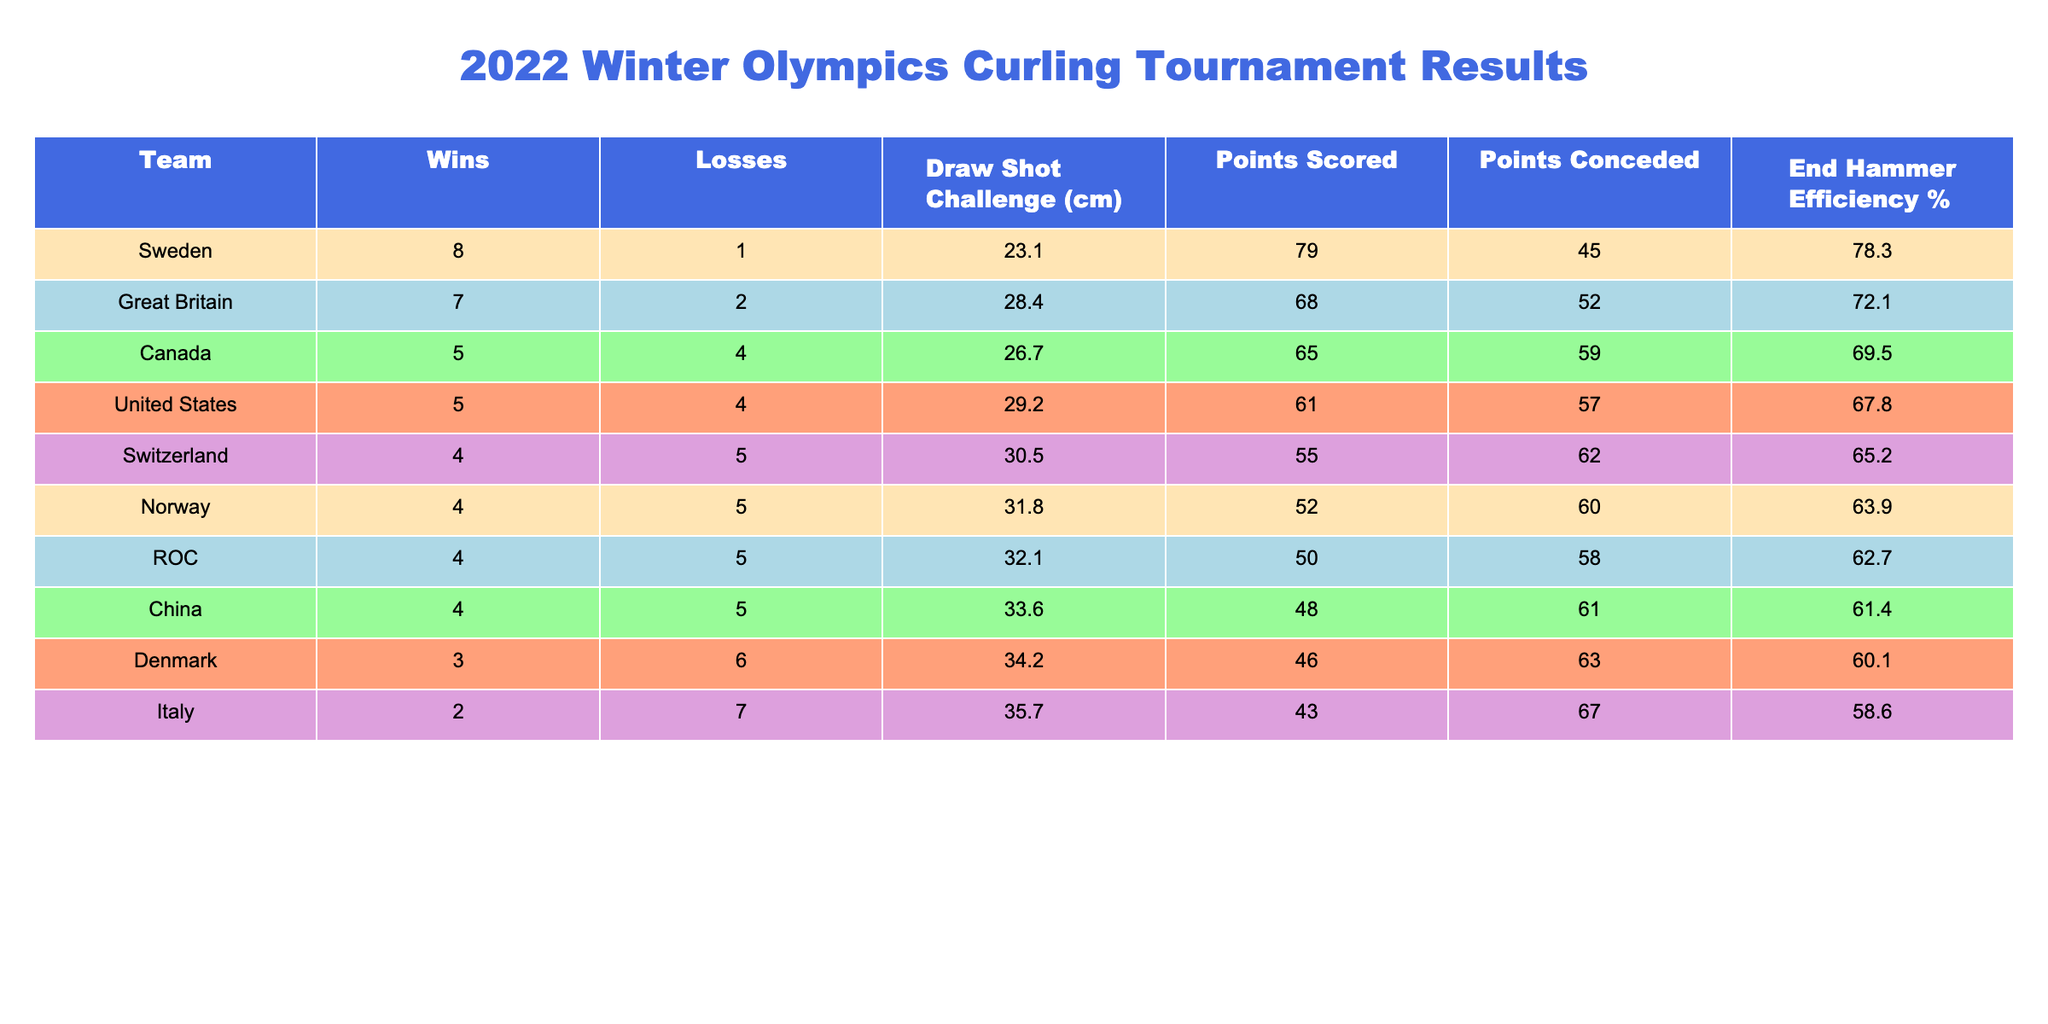What is the total number of wins for all teams? To find the total number of wins, we sum the wins for each team: 8 + 7 + 5 + 5 + 4 + 4 + 4 + 4 + 3 + 2 = 56.
Answer: 56 Which team conceded the most points? By looking at the "Points Conceded" column, we identify that Canada with 59 points conceded the most.
Answer: Canada What is the win-loss ratio for Sweden? The win-loss ratio is calculated as wins divided by losses: 8 wins / 1 loss = 8.0.
Answer: 8.0 Did any team have a Draw Shot Challenge value below 25 cm? Checking the "Draw Shot Challenge (cm)" column, Sweden had 23.1 cm, which is below 25 cm.
Answer: Yes What is the total number of points scored by the teams with 5 or more wins? The teams with 5 or more wins are Sweden (79), Great Britain (68), and Canada (65). We sum these: 79 + 68 + 65 = 212 points.
Answer: 212 Which team had the highest End Hammer Efficiency percentage? By reviewing the "End Hammer Efficiency %" column, Sweden has the highest efficiency at 78.3%.
Answer: Sweden What is the average number of points scored by all teams? To find the average, sum the points scored (79 + 68 + 65 + 61 + 55 + 52 + 50 + 48 + 46 + 43 =  60.7 total points), then divide by the number of teams (10):  640/10 = 64.0 average points.
Answer: 64.0 Which team has the best win-loss ratio among the bottom three teams? The bottom three teams are Italy (2 wins, 7 losses), Denmark (3 wins, 6 losses), and ROC (4 wins, 5 losses). Their ratios are 0.29, 0.50, and 0.80, respectively. ROC has the best ratio.
Answer: ROC How many teams had a win-loss record below .500? The teams with a win-loss record below .500 are Switzerland, Norway, ROC, China, Denmark, and Italy, totaling 6 teams.
Answer: 6 Calculate the difference in End Hammer Efficiency between Sweden and China. Sweden's efficiency is 78.3% and China's is 61.4%. Thus, the difference is 78.3 - 61.4 = 16.9%.
Answer: 16.9% 